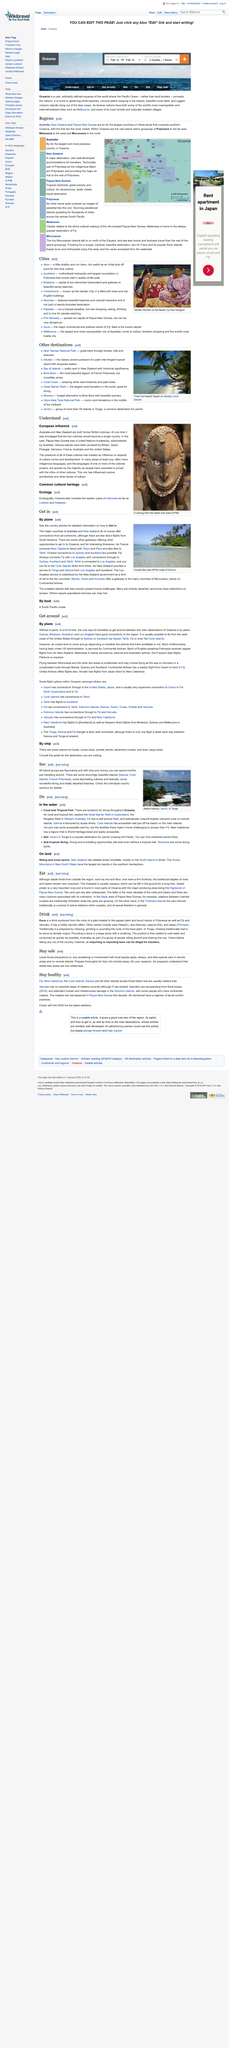Specify some key components in this picture. It is important to always exercise travel precautions, including socializing and involvement with local people, especially in remote areas and on remote islands where the risk of criminal activity may be higher. Oceania is comprised of several regions, including Australia, New Zealand, and Papua New Guinea, as well as the island nation groups of Polynesia, Melanesia, and Micronesia. Los Angeles has excellent connectivity to the Oceania region, making it a prime destination for travelers seeking a seamless trip to this beautiful part of the world. Some islands that are typically free from malaria are Fiji, New Caledonia, the Cook Islands, and Samoa. In Oceania, cassava is commonly recognized as the most affordable staple food. 